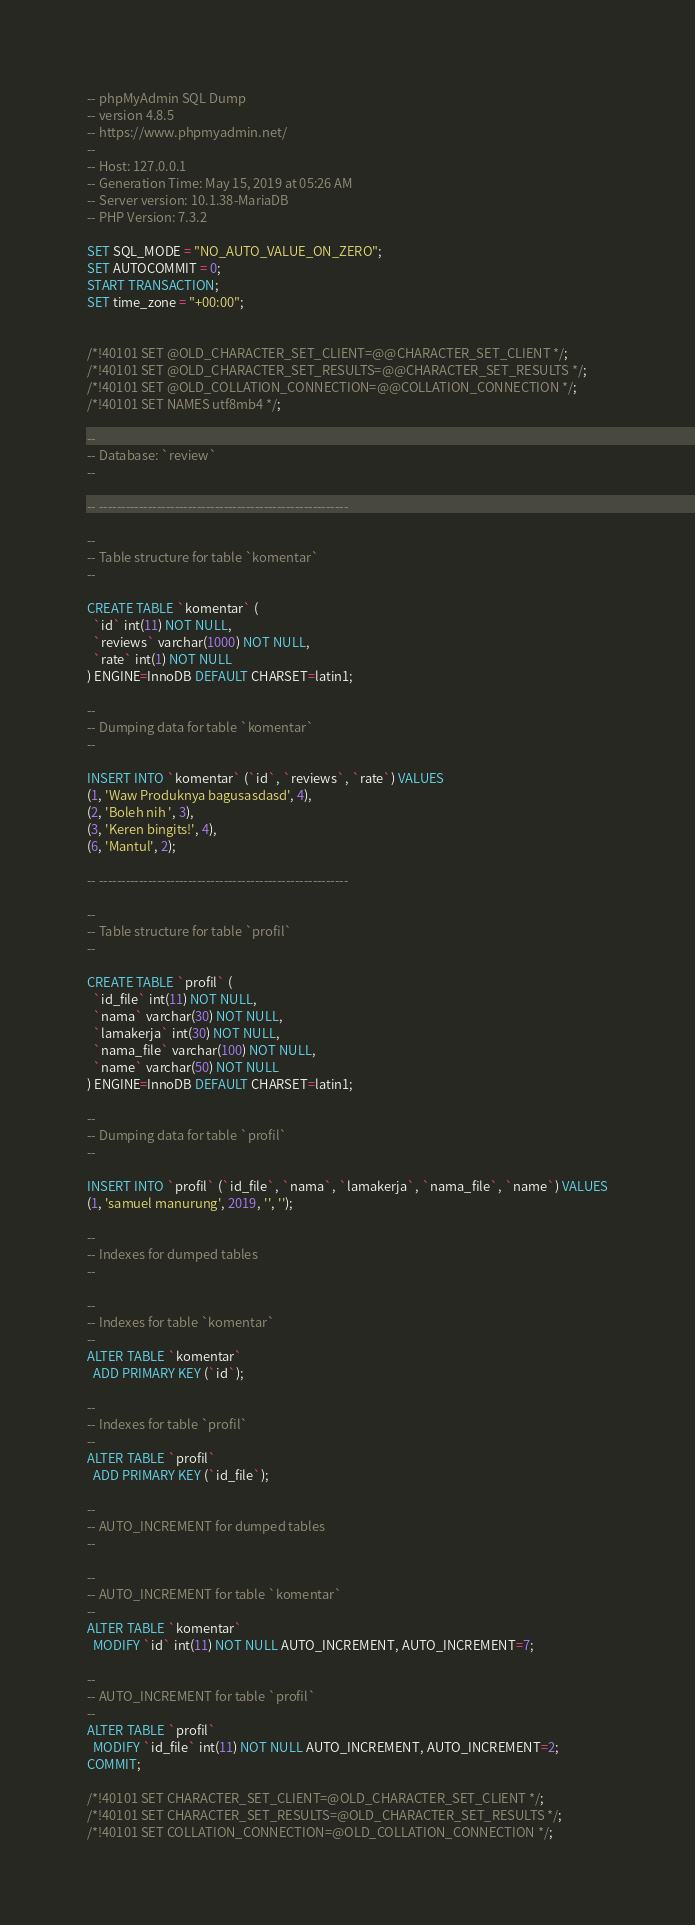Convert code to text. <code><loc_0><loc_0><loc_500><loc_500><_SQL_>-- phpMyAdmin SQL Dump
-- version 4.8.5
-- https://www.phpmyadmin.net/
--
-- Host: 127.0.0.1
-- Generation Time: May 15, 2019 at 05:26 AM
-- Server version: 10.1.38-MariaDB
-- PHP Version: 7.3.2

SET SQL_MODE = "NO_AUTO_VALUE_ON_ZERO";
SET AUTOCOMMIT = 0;
START TRANSACTION;
SET time_zone = "+00:00";


/*!40101 SET @OLD_CHARACTER_SET_CLIENT=@@CHARACTER_SET_CLIENT */;
/*!40101 SET @OLD_CHARACTER_SET_RESULTS=@@CHARACTER_SET_RESULTS */;
/*!40101 SET @OLD_COLLATION_CONNECTION=@@COLLATION_CONNECTION */;
/*!40101 SET NAMES utf8mb4 */;

--
-- Database: `review`
--

-- --------------------------------------------------------

--
-- Table structure for table `komentar`
--

CREATE TABLE `komentar` (
  `id` int(11) NOT NULL,
  `reviews` varchar(1000) NOT NULL,
  `rate` int(1) NOT NULL
) ENGINE=InnoDB DEFAULT CHARSET=latin1;

--
-- Dumping data for table `komentar`
--

INSERT INTO `komentar` (`id`, `reviews`, `rate`) VALUES
(1, 'Waw Produknya bagusasdasd', 4),
(2, 'Boleh nih ', 3),
(3, 'Keren bingits!', 4),
(6, 'Mantul', 2);

-- --------------------------------------------------------

--
-- Table structure for table `profil`
--

CREATE TABLE `profil` (
  `id_file` int(11) NOT NULL,
  `nama` varchar(30) NOT NULL,
  `lamakerja` int(30) NOT NULL,
  `nama_file` varchar(100) NOT NULL,
  `name` varchar(50) NOT NULL
) ENGINE=InnoDB DEFAULT CHARSET=latin1;

--
-- Dumping data for table `profil`
--

INSERT INTO `profil` (`id_file`, `nama`, `lamakerja`, `nama_file`, `name`) VALUES
(1, 'samuel manurung', 2019, '', '');

--
-- Indexes for dumped tables
--

--
-- Indexes for table `komentar`
--
ALTER TABLE `komentar`
  ADD PRIMARY KEY (`id`);

--
-- Indexes for table `profil`
--
ALTER TABLE `profil`
  ADD PRIMARY KEY (`id_file`);

--
-- AUTO_INCREMENT for dumped tables
--

--
-- AUTO_INCREMENT for table `komentar`
--
ALTER TABLE `komentar`
  MODIFY `id` int(11) NOT NULL AUTO_INCREMENT, AUTO_INCREMENT=7;

--
-- AUTO_INCREMENT for table `profil`
--
ALTER TABLE `profil`
  MODIFY `id_file` int(11) NOT NULL AUTO_INCREMENT, AUTO_INCREMENT=2;
COMMIT;

/*!40101 SET CHARACTER_SET_CLIENT=@OLD_CHARACTER_SET_CLIENT */;
/*!40101 SET CHARACTER_SET_RESULTS=@OLD_CHARACTER_SET_RESULTS */;
/*!40101 SET COLLATION_CONNECTION=@OLD_COLLATION_CONNECTION */;
</code> 